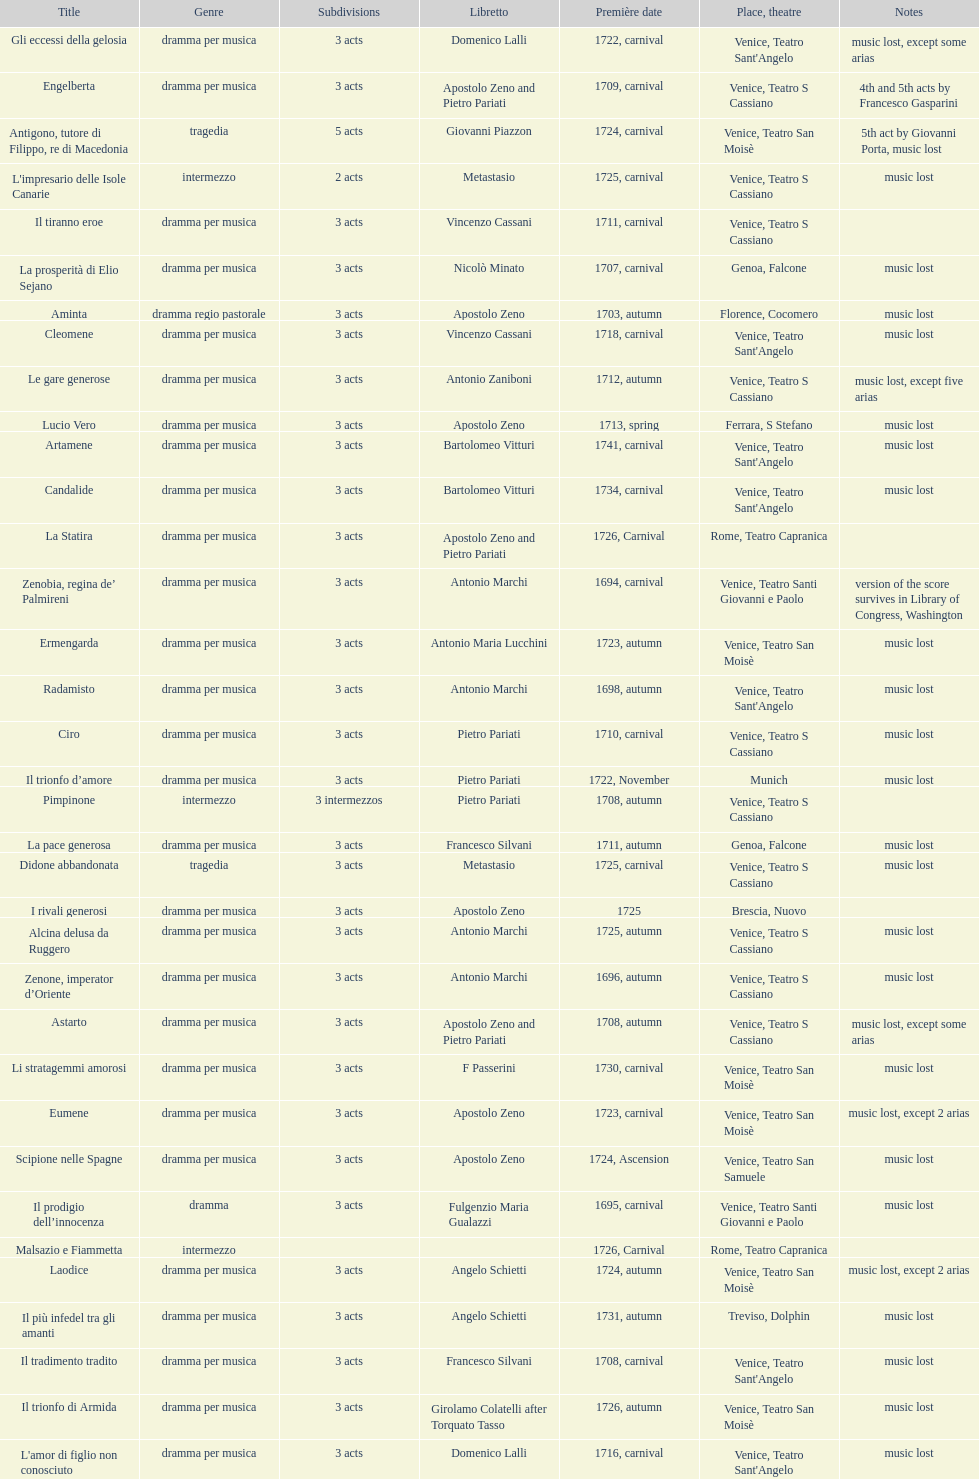L'inganno innocente premiered in 1701. what was the previous title released? Diomede punito da Alcide. 